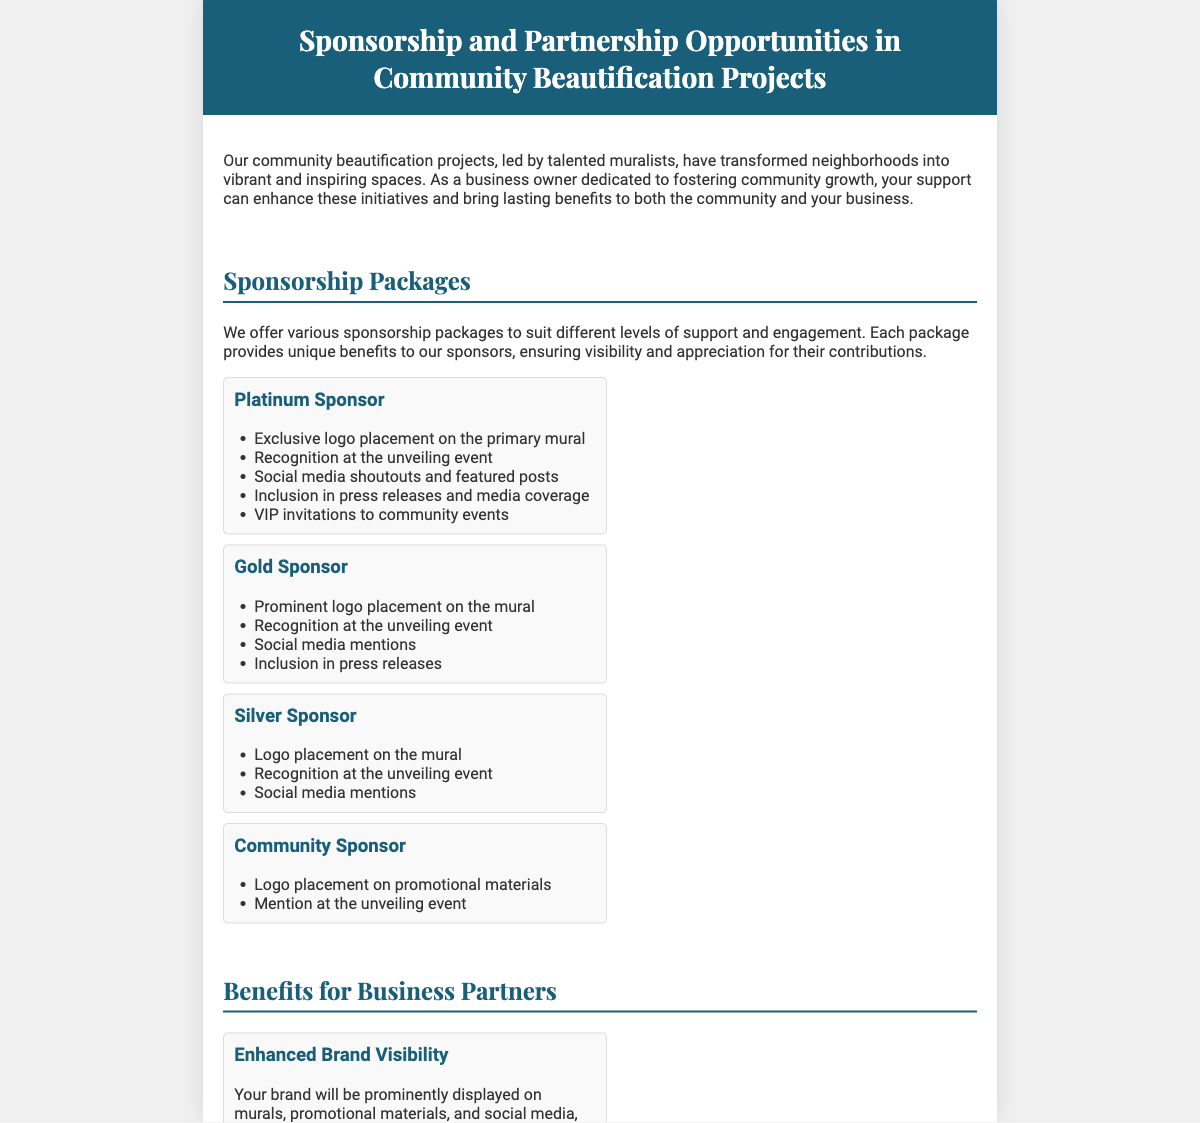What is the title of the Playbill? The title of the Playbill describes the focus on sponsorship opportunities in community beautification projects.
Answer: Sponsorship and Partnership Opportunities in Community Beautification Projects How many sponsorship packages are listed? The document details four specific sponsorship packages available for businesses and partners.
Answer: Four What is the highest sponsorship package? The document explicitly ranks the packages by level of support, with one being the most premium.
Answer: Platinum Sponsor Which company contributed to the School Mural Project? The success stories section names a particular company that funded this specific initiative for schools.
Answer: DEF Industries What benefit involves media coverage? Several benefits listed for business partners include types of publicity associated with community projects.
Answer: Positive PR and Media Exposure What is one requirement for a Platinum Sponsor? The responsibilities or offerings for the top sponsorship tier are outlined in the package section, highlighting exclusivity and visibility attributes.
Answer: Exclusive logo placement on the primary mural What is the main theme of the document? The document's overall content is centered around engaging businesses for community enhancement through mural art.
Answer: Community Beautification Projects Which tier offers social media mentions? The benefits of each sponsorship tier are detailed, showing the presence of social media engagement across different packages.
Answer: Gold, Silver, and Platinum Sponsors 